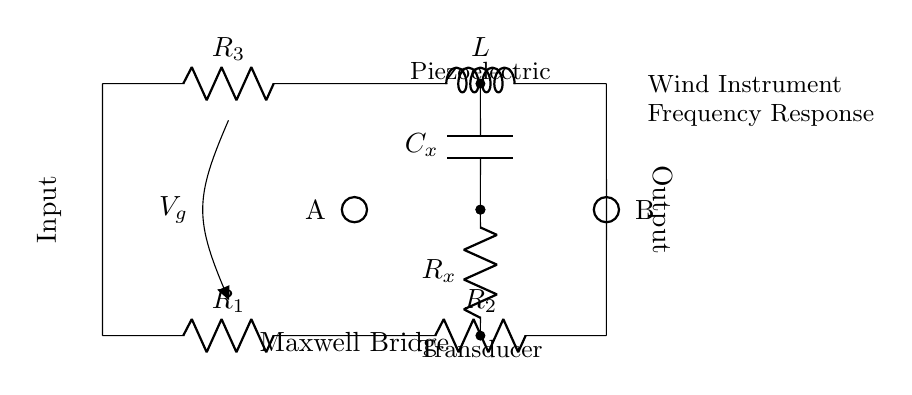What type of circuit is represented here? The circuit is a Maxwell Bridge, which is specifically designed for measuring unknown electrical components by balancing them against known components in a bridge configuration. The presence of the label "Maxwell Bridge" at the bottom confirms this.
Answer: Maxwell Bridge What components are present in the circuit? The circuit diagram includes resistors, an inductor, and a capacitor. These components are labeled as R1, R2, R3, L, Rx, and Cx, allowing us to identify them visually and by their labels.
Answer: Resistors, inductor, capacitor What is the role of the piezoelectric transducer? The piezoelectric transducer converts mechanical vibrations into electrical signals. In this circuit, it is likely being characterized for its frequency response, as indicated by the labeling in the diagram.
Answer: Conversion of mechanical vibrations How many resistors are in the circuit? There are three resistors labeled R1, R2, and R3. The circuit visually confirms their presence and labels them clearly.
Answer: Three What does the voltage symbol 'Vg' represent in this circuit? The voltage symbol 'Vg' represents the applied input voltage to the Maxwell Bridge. This voltage is the potential difference driving the current through the circuit for analysis.
Answer: Input voltage What connections are made on the left and right sides of the circuit? On the left side, there is an input connection, and on the right side, there is an output connection. The labels 'Input' and 'Output' next to the respective sides help identify these connections.
Answer: Input and output What is the purpose of the inductance L in this circuit? The inductor L is used to balance the reactive components of the circuit during analysis. Its presence helps in tuning the circuit to measure the frequency response accurately, crucial for the functionality of the Maxwell Bridge.
Answer: Balancing reactive components 